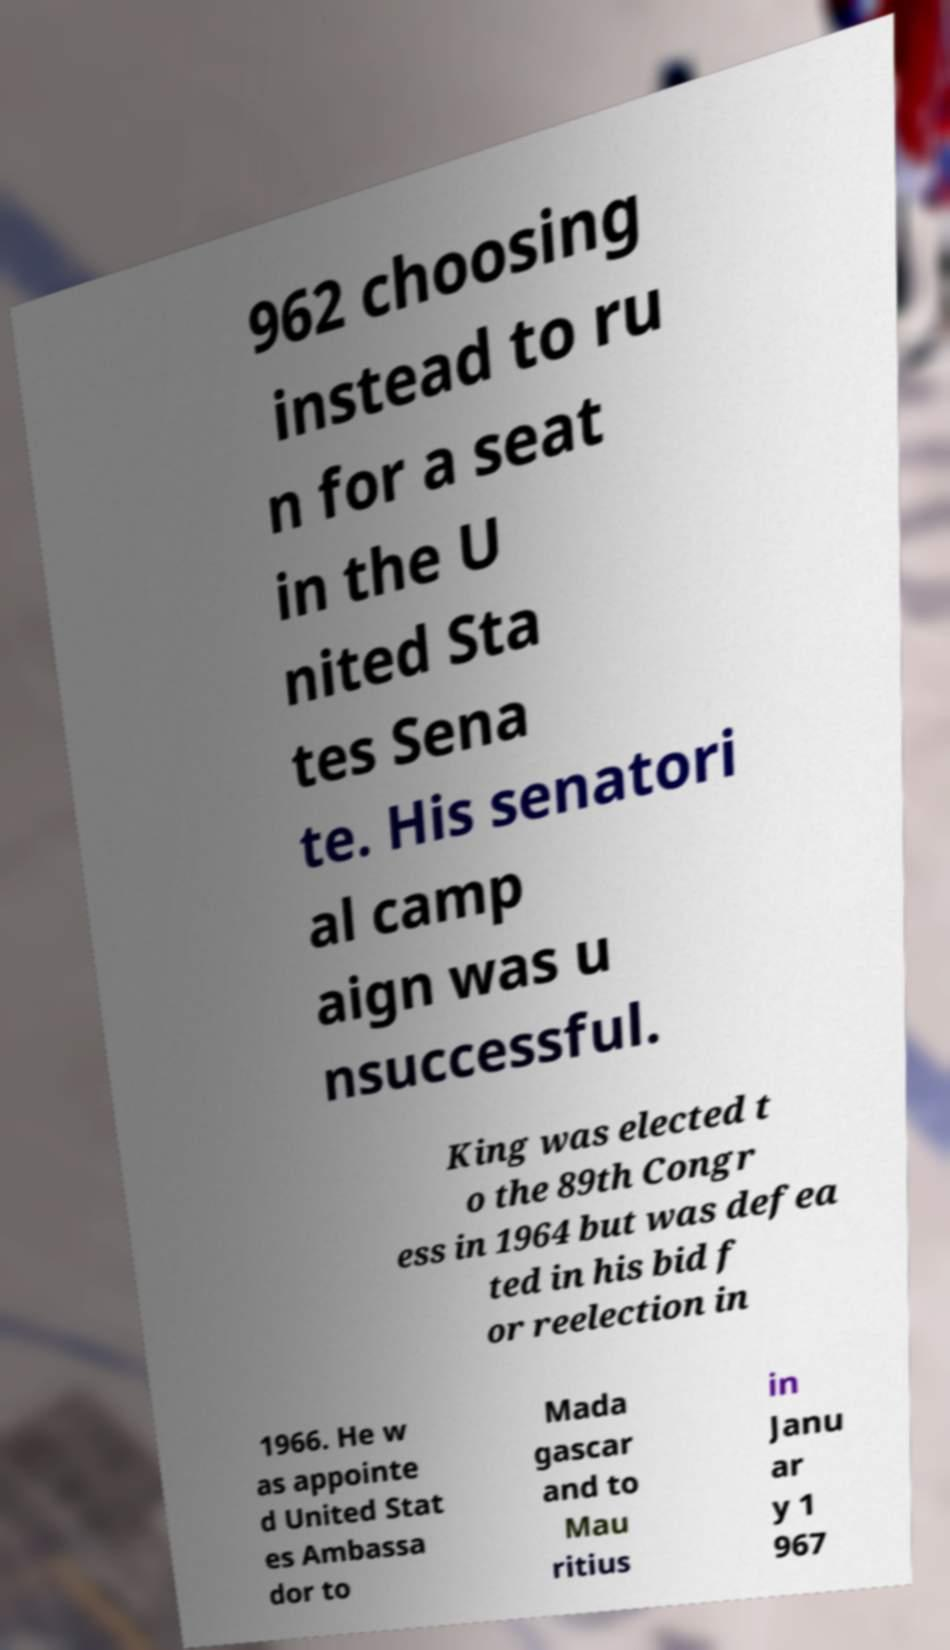Could you extract and type out the text from this image? 962 choosing instead to ru n for a seat in the U nited Sta tes Sena te. His senatori al camp aign was u nsuccessful. King was elected t o the 89th Congr ess in 1964 but was defea ted in his bid f or reelection in 1966. He w as appointe d United Stat es Ambassa dor to Mada gascar and to Mau ritius in Janu ar y 1 967 